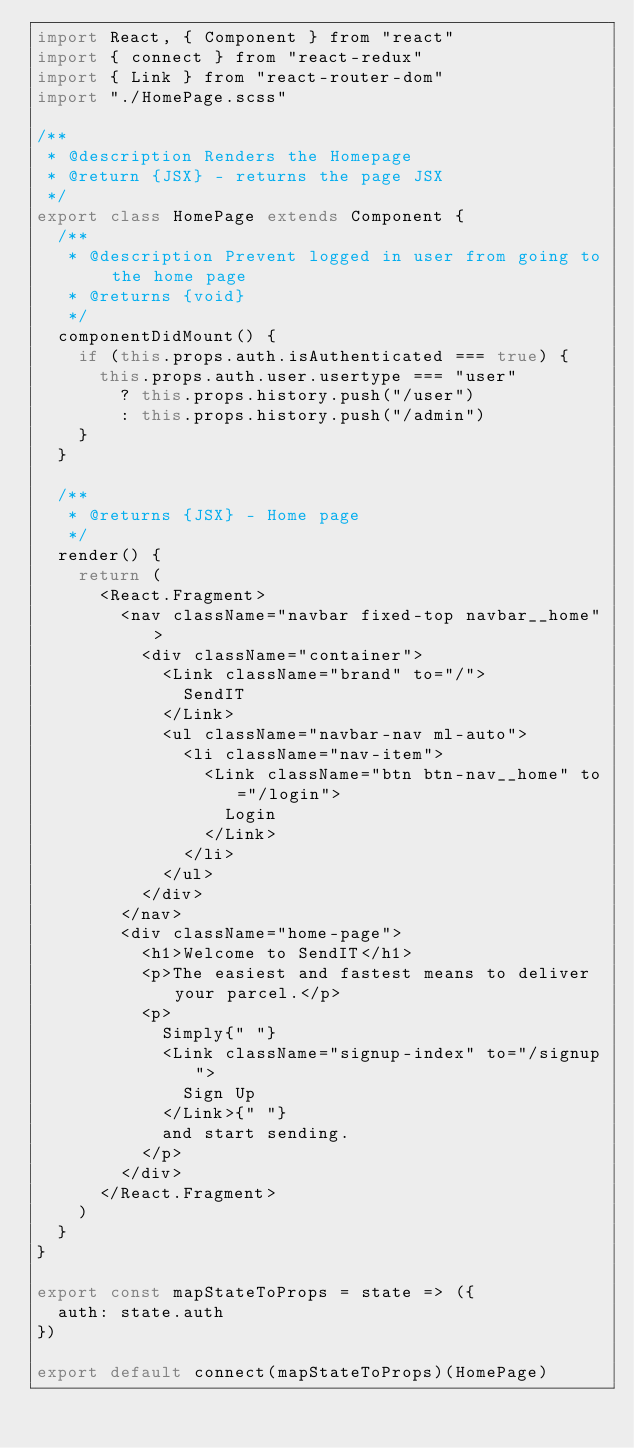<code> <loc_0><loc_0><loc_500><loc_500><_JavaScript_>import React, { Component } from "react"
import { connect } from "react-redux"
import { Link } from "react-router-dom"
import "./HomePage.scss"

/**
 * @description Renders the Homepage
 * @return {JSX} - returns the page JSX
 */
export class HomePage extends Component {
  /**
   * @description Prevent logged in user from going to the home page
   * @returns {void}
   */
  componentDidMount() {
    if (this.props.auth.isAuthenticated === true) {
      this.props.auth.user.usertype === "user"
        ? this.props.history.push("/user")
        : this.props.history.push("/admin")
    }
  }

  /**
   * @returns {JSX} - Home page
   */
  render() {
    return (
      <React.Fragment>
        <nav className="navbar fixed-top navbar__home">
          <div className="container">
            <Link className="brand" to="/">
              SendIT
            </Link>
            <ul className="navbar-nav ml-auto">
              <li className="nav-item">
                <Link className="btn btn-nav__home" to="/login">
                  Login
                </Link>
              </li>
            </ul>
          </div>
        </nav>
        <div className="home-page">
          <h1>Welcome to SendIT</h1>
          <p>The easiest and fastest means to deliver your parcel.</p>
          <p>
            Simply{" "}
            <Link className="signup-index" to="/signup">
              Sign Up
            </Link>{" "}
            and start sending.
          </p>
        </div>
      </React.Fragment>
    )
  }
}

export const mapStateToProps = state => ({
  auth: state.auth
})

export default connect(mapStateToProps)(HomePage)
</code> 